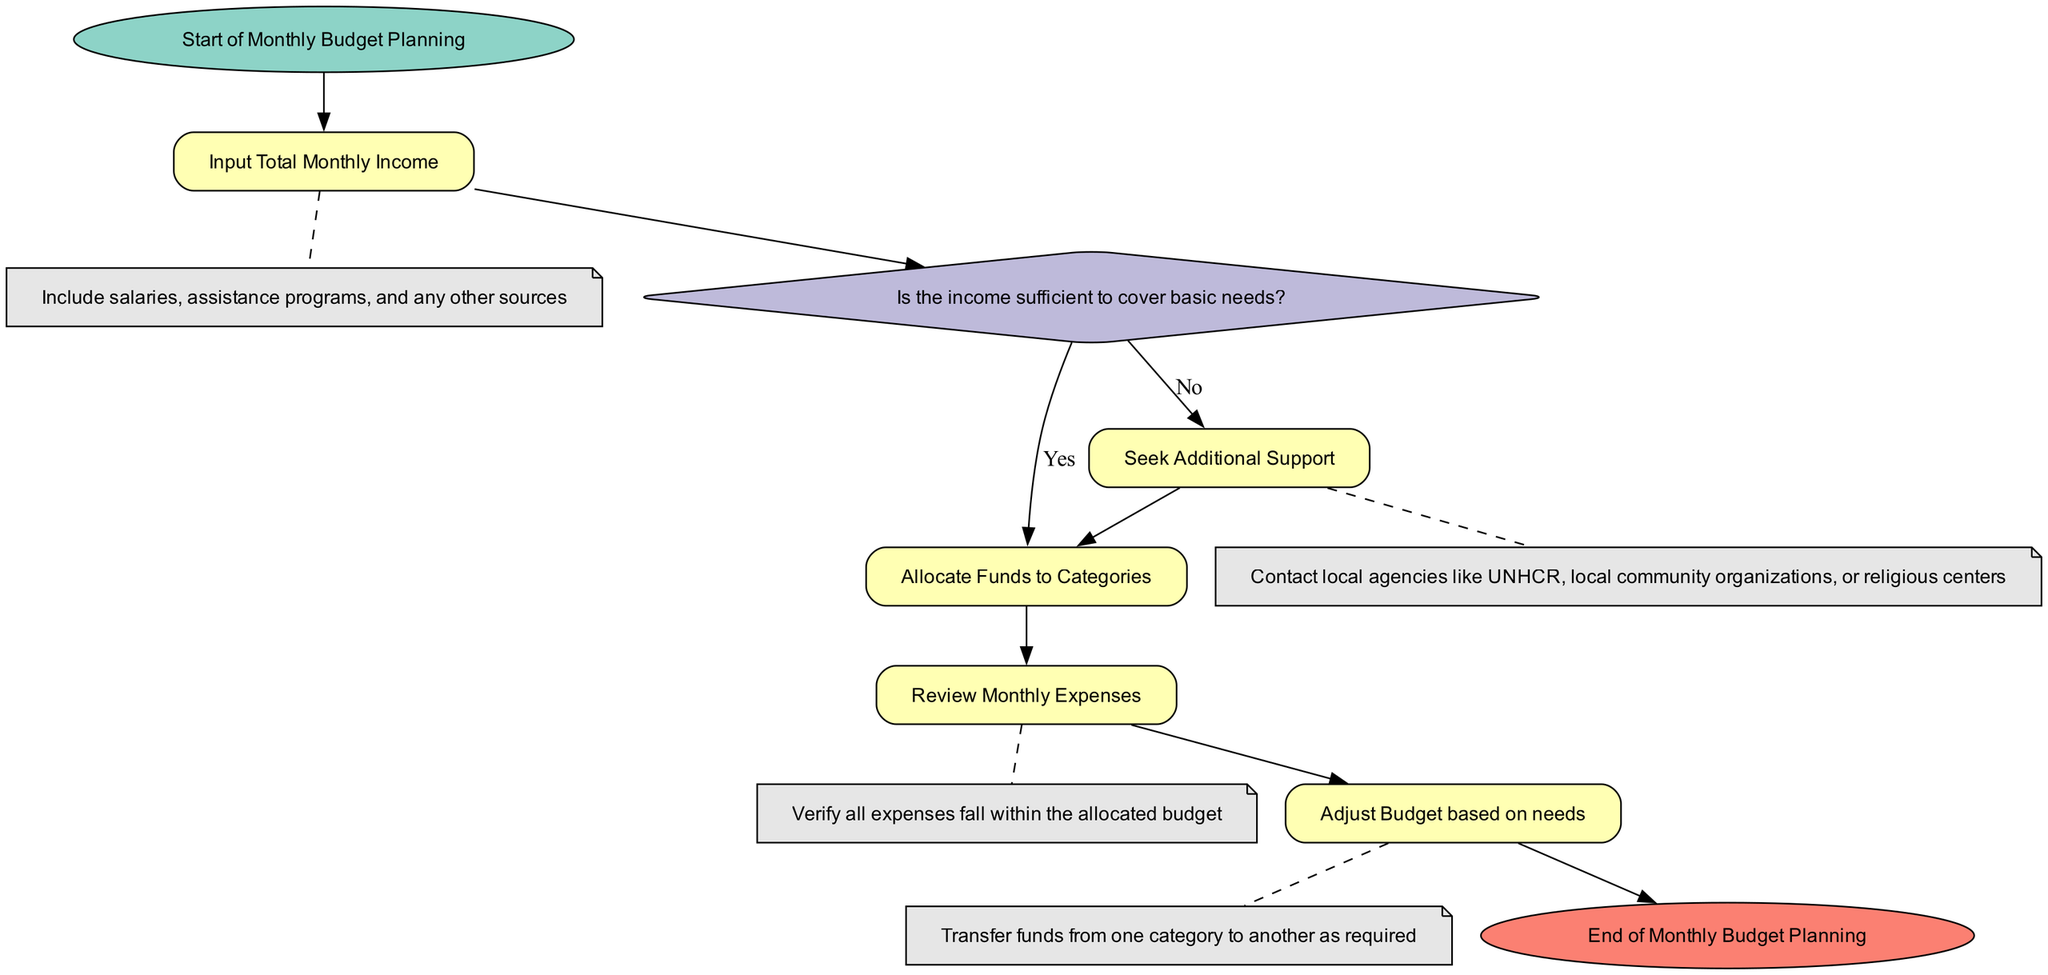What is the first step in the Monthly Budget Planning process? The first step is represented by the "start" node, which indicates the initiation of the Monthly Budget Planning.
Answer: Start of Monthly Budget Planning How many categories are funds allocated to? The "allocate_expenses" process specifies a list of seven categories for budget allocation: Rent, Utilities, Groceries, Transportation, Healthcare, Savings, and Miscellaneous.
Answer: Seven What happens when the income is insufficient? The flowchart indicates that if the income is insufficient, the next step is to "Seek Additional Support," as indicated by the decision node's "No" output.
Answer: Seek Additional Support What is the next action after reviewing monthly expenses? Following the "Review Monthly Expenses" process, the subsequent action outlined in the flowchart is to "Adjust Budget based on needs."
Answer: Adjust Budget based on needs Which organizations are suggested for seeking additional support? The "Seek Additional Support" process notes that one should contact local agencies such as UNHCR, local community organizations, or religious centers for assistance.
Answer: UNHCR, local community organizations, religious centers In total, how many processes are present in the diagram? The diagram consists of a total of five process nodes: Input Total Monthly Income, Allocate Funds to Categories, Review Monthly Expenses, Adjust Budget based on needs, and Seek Additional Support.
Answer: Five What type of node is 'check_income'? The 'check_income' node is a decision node that determines if the income covers basic needs, based on the flow structure highlighted in the diagram.
Answer: Decision What is indicated by the 'end' node in the diagram? The 'end' node signifies the conclusion of the Monthly Budget Planning process, where all actions are completed and the budgeting process is finalized.
Answer: End of Monthly Budget Planning 